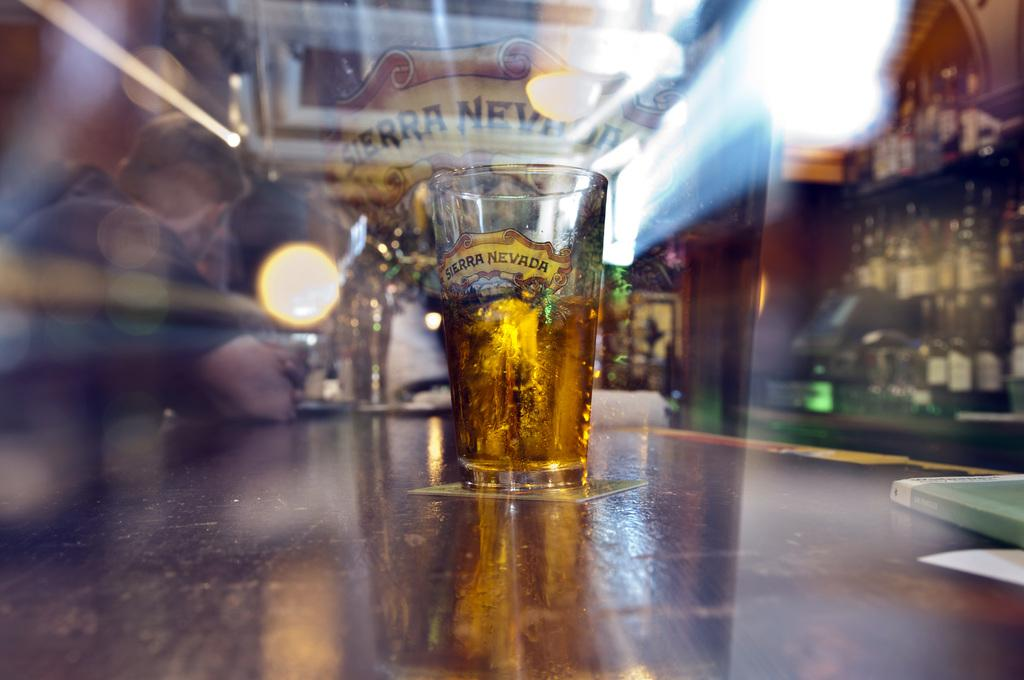<image>
Provide a brief description of the given image. A beer glass with the name Sierra Nevada printed on it with a yellow background. 